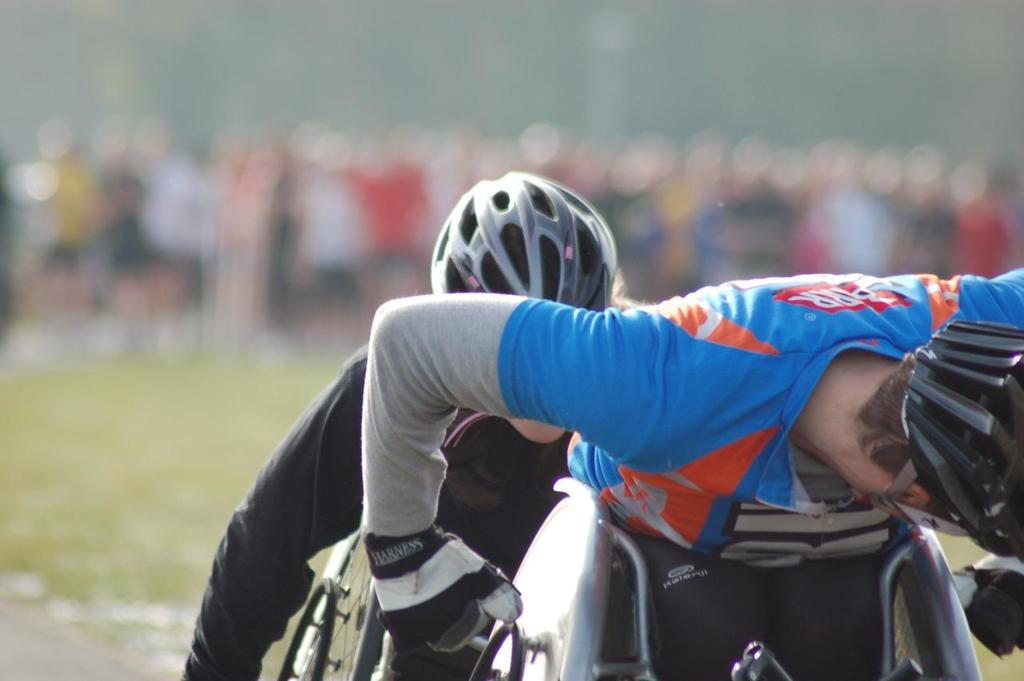How many people are in the image? There are people in the image. What are two of the people doing in the image? Two of the people are riding on wheelchairs. What protective gear are the people wearing? The people are wearing helmets. Can you describe the background of the image? The background of the image is blurred. What type of breakfast is being served in the image? There is no breakfast present in the image. What reward is being given to the people in the image? There is no reward being given in the image; the people are simply wearing helmets and riding on wheelchairs. 